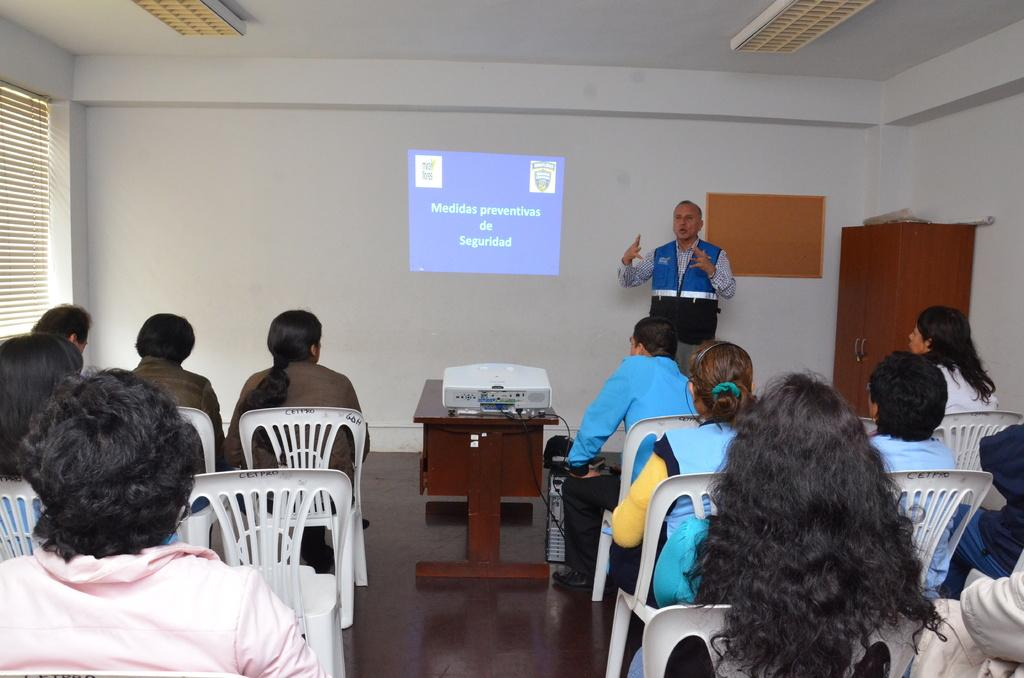What type of structure can be seen in the image? There is a wall in the image. What is located near the wall? There is a screen in the image. What are the people in the image doing? There are people sitting on chairs in the image. What is on the table in the image? There is a projector on the table in the image. What might be used for displaying visuals during a presentation or event? The projector on the table can be used for displaying visuals. What type of potato is being used as a chess piece in the image? There is no potato or chess game present in the image. 